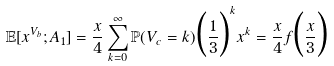<formula> <loc_0><loc_0><loc_500><loc_500>\mathbb { E } [ x ^ { V _ { b } } ; A _ { 1 } ] = \frac { x } { 4 } \sum _ { k = 0 } ^ { \infty } \mathbb { P } ( V _ { c } = k ) \Big { ( } \frac { 1 } { 3 } \Big { ) } ^ { k } x ^ { k } = \frac { x } { 4 } f \Big { ( } \frac { x } { 3 } \Big { ) }</formula> 